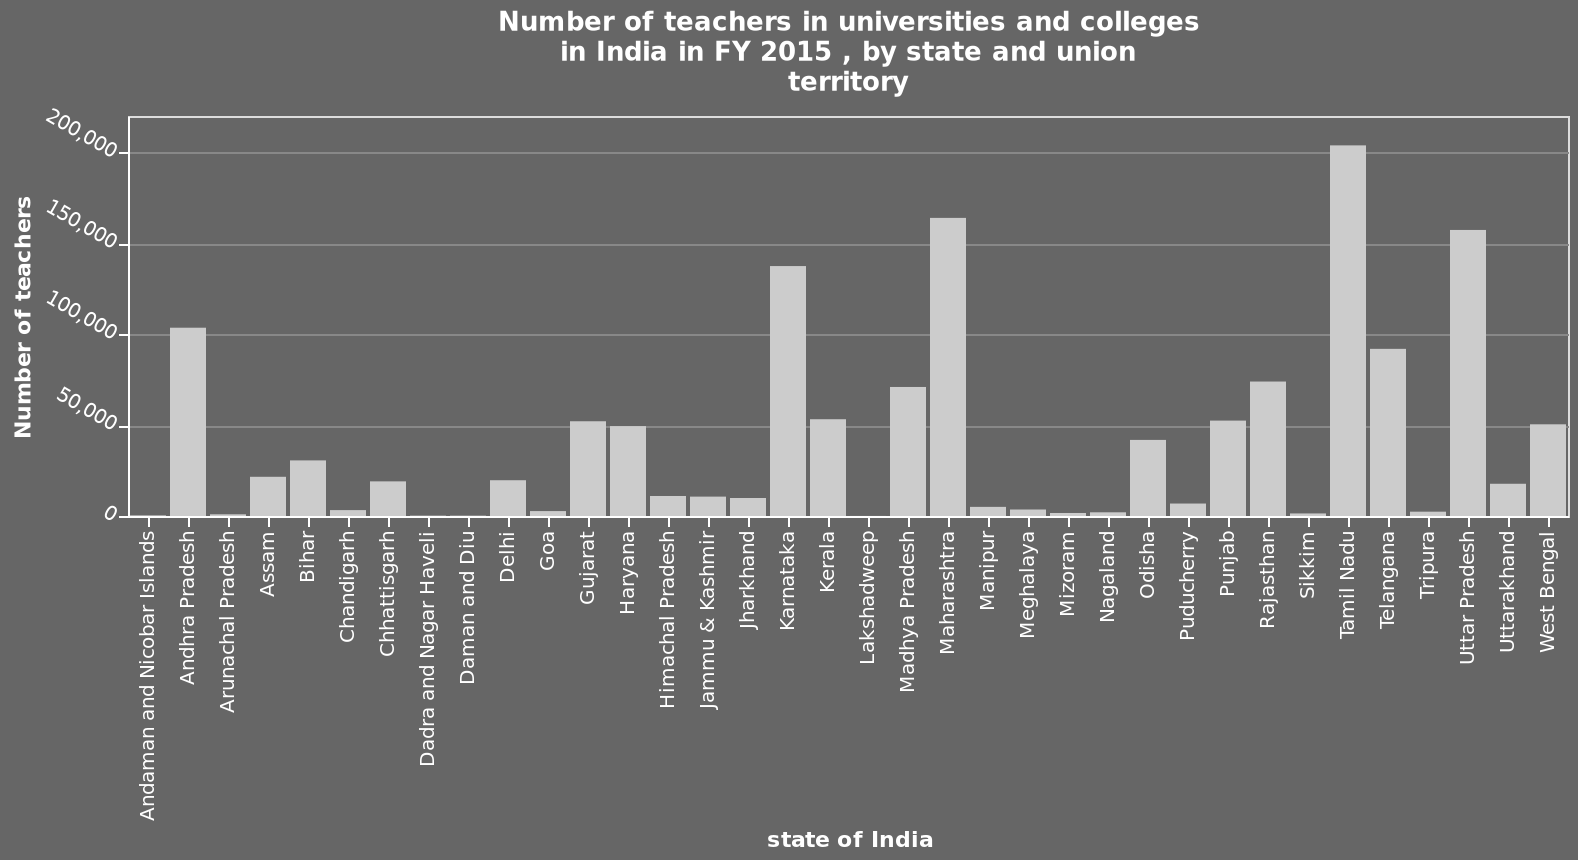<image>
What is the variation in the number of teachers? The variation ranges from a negligible amount of teachers to an excess of 200,000. How consistent are the bars in the data?  The bars are totally inconsistent. What time period does the bar chart represent?  The bar chart represents the data for FY 2015 (Fiscal Year 2015). Describe the following image in detail Here a is a bar chart called Number of teachers in universities and colleges in India in FY 2015 , by state and union territory. The x-axis shows state of India while the y-axis measures Number of teachers. Does the variation range from an excessive amount of teachers to a negligible amount of 200,000? No.The variation ranges from a negligible amount of teachers to an excess of 200,000. 